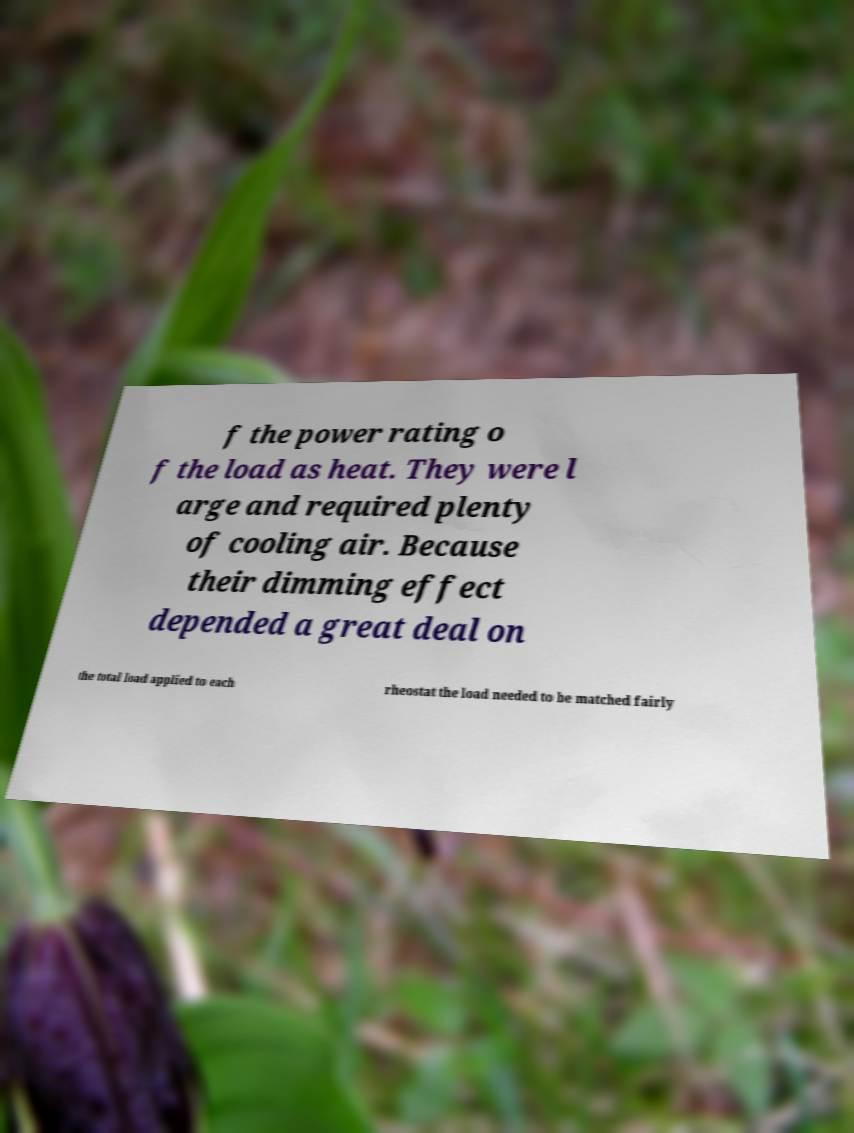Can you read and provide the text displayed in the image?This photo seems to have some interesting text. Can you extract and type it out for me? f the power rating o f the load as heat. They were l arge and required plenty of cooling air. Because their dimming effect depended a great deal on the total load applied to each rheostat the load needed to be matched fairly 